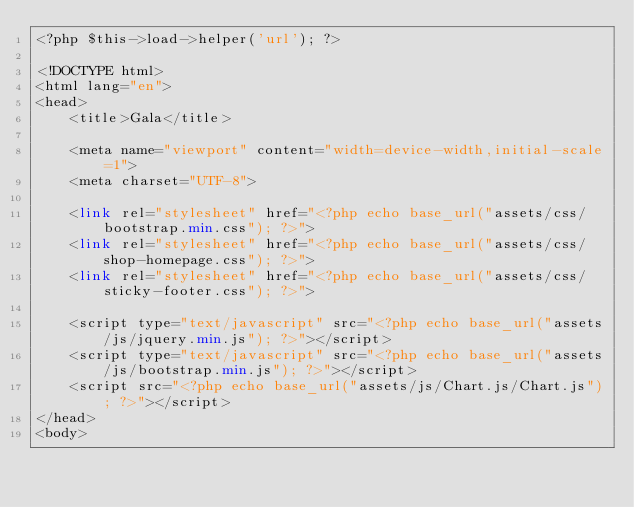Convert code to text. <code><loc_0><loc_0><loc_500><loc_500><_PHP_><?php $this->load->helper('url'); ?>

<!DOCTYPE html>
<html lang="en">
<head>
	<title>Gala</title>

	<meta name="viewport" content="width=device-width,initial-scale=1">
	<meta charset="UTF-8">

	<link rel="stylesheet" href="<?php echo base_url("assets/css/bootstrap.min.css"); ?>">
	<link rel="stylesheet" href="<?php echo base_url("assets/css/shop-homepage.css"); ?>">
	<link rel="stylesheet" href="<?php echo base_url("assets/css/sticky-footer.css"); ?>">

	<script type="text/javascript" src="<?php echo base_url("assets/js/jquery.min.js"); ?>"></script>
	<script type="text/javascript" src="<?php echo base_url("assets/js/bootstrap.min.js"); ?>"></script>
	<script src="<?php echo base_url("assets/js/Chart.js/Chart.js"); ?>"></script>
</head>
<body></code> 